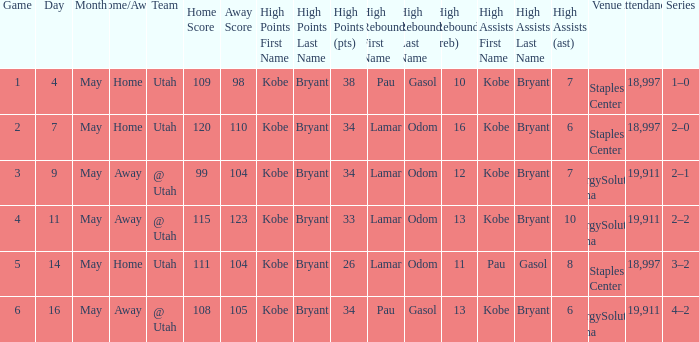What is the High rebounds with a High assists with bryant (7), and a Team of @ utah? Odom (12). Would you be able to parse every entry in this table? {'header': ['Game', 'Day', 'Month', 'Home/Away', 'Team', 'Home Score', 'Away Score', 'High Points First Name', 'High Points Last Name', 'High Points (pts)', 'High Rebounds First Name', 'High Rebounds Last Name', 'High Rebounds (reb)', 'High Assists First Name', 'High Assists Last Name', 'High Assists (ast)', 'Venue', 'Attendance', 'Series'], 'rows': [['1', '4', 'May', 'Home', 'Utah', '109', '98', 'Kobe', 'Bryant', '38', 'Pau', 'Gasol', '10', 'Kobe', 'Bryant', '7', 'Staples Center', '18,997', '1–0'], ['2', '7', 'May', 'Home', 'Utah', '120', '110', 'Kobe', 'Bryant', '34', 'Lamar', 'Odom', '16', 'Kobe', 'Bryant', '6', 'Staples Center', '18,997', '2–0'], ['3', '9', 'May', 'Away', '@ Utah', '99', '104', 'Kobe', 'Bryant', '34', 'Lamar', 'Odom', '12', 'Kobe', 'Bryant', '7', 'EnergySolutions Arena', '19,911', '2–1'], ['4', '11', 'May', 'Away', '@ Utah', '115', '123', 'Kobe', 'Bryant', '33', 'Lamar', 'Odom', '13', 'Kobe', 'Bryant', '10', 'EnergySolutions Arena', '19,911', '2–2'], ['5', '14', 'May', 'Home', 'Utah', '111', '104', 'Kobe', 'Bryant', '26', 'Lamar', 'Odom', '11', 'Pau', 'Gasol', '8', 'Staples Center', '18,997', '3–2'], ['6', '16', 'May', 'Away', '@ Utah', '108', '105', 'Kobe', 'Bryant', '34', 'Pau', 'Gasol', '13', 'Kobe', 'Bryant', '6', 'EnergySolutions Arena', '19,911', '4–2']]} 